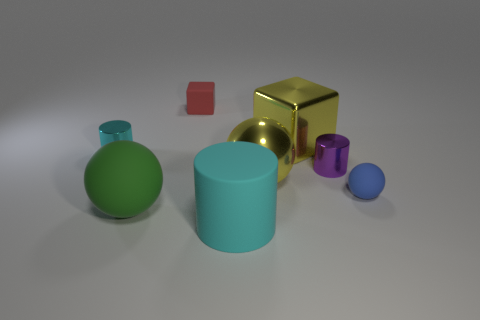Add 1 tiny cubes. How many objects exist? 9 Subtract all cylinders. How many objects are left? 5 Subtract all big matte cylinders. Subtract all green matte balls. How many objects are left? 6 Add 2 tiny blue objects. How many tiny blue objects are left? 3 Add 3 large cyan cylinders. How many large cyan cylinders exist? 4 Subtract 0 purple blocks. How many objects are left? 8 